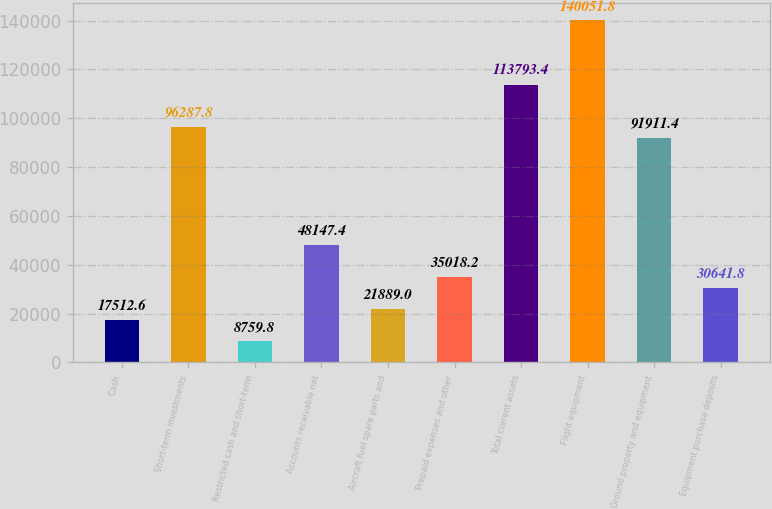Convert chart to OTSL. <chart><loc_0><loc_0><loc_500><loc_500><bar_chart><fcel>Cash<fcel>Short-term investments<fcel>Restricted cash and short-term<fcel>Accounts receivable net<fcel>Aircraft fuel spare parts and<fcel>Prepaid expenses and other<fcel>Total current assets<fcel>Flight equipment<fcel>Ground property and equipment<fcel>Equipment purchase deposits<nl><fcel>17512.6<fcel>96287.8<fcel>8759.8<fcel>48147.4<fcel>21889<fcel>35018.2<fcel>113793<fcel>140052<fcel>91911.4<fcel>30641.8<nl></chart> 